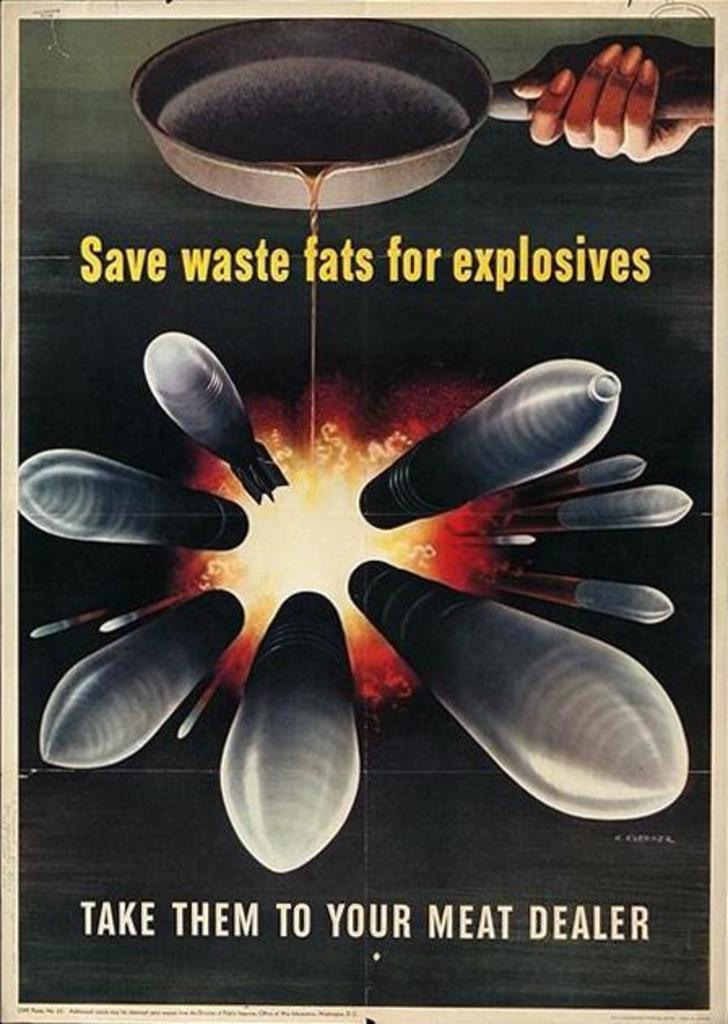What type of image is being described? The image is a poster. What is the person's hand doing in the poster? The person's hand is holding a pan in the poster. Are there any words or phrases on the poster? Yes, there is text in the poster. What other objects or elements can be seen in the poster? There are missiles and fire in the poster. Can you see a kitten playing with a hose in the poster? No, there is no kitten or hose present in the poster. What type of juice is being served in the poster? There is no juice being served in the poster; it features a person's hand holding a pan, missiles, fire, and text. 